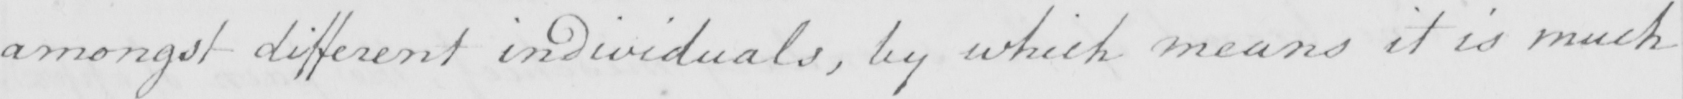Transcribe the text shown in this historical manuscript line. amongst different individuals , by which means it is much 